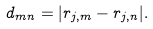Convert formula to latex. <formula><loc_0><loc_0><loc_500><loc_500>d _ { m n } = | r _ { j , m } - r _ { j , n } | .</formula> 